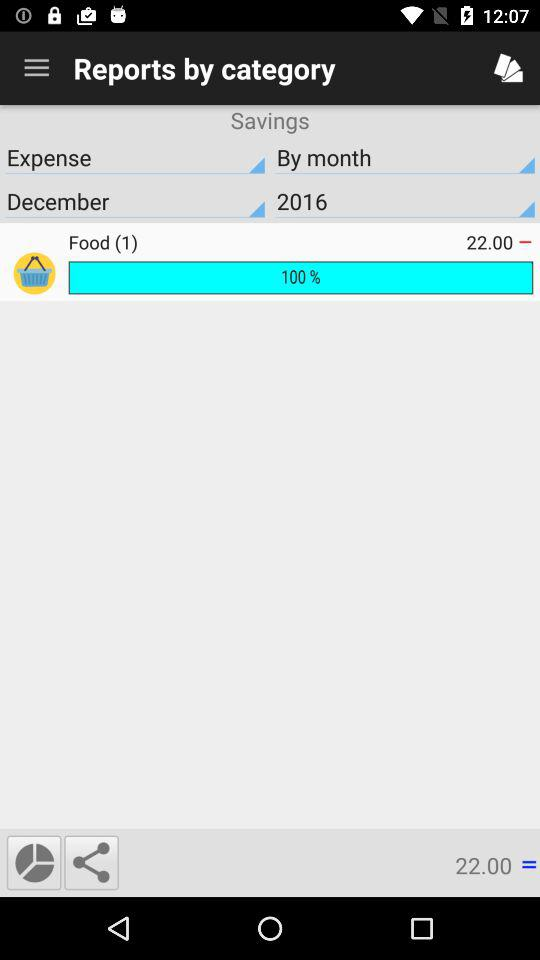What is the year? The year is 2016. 